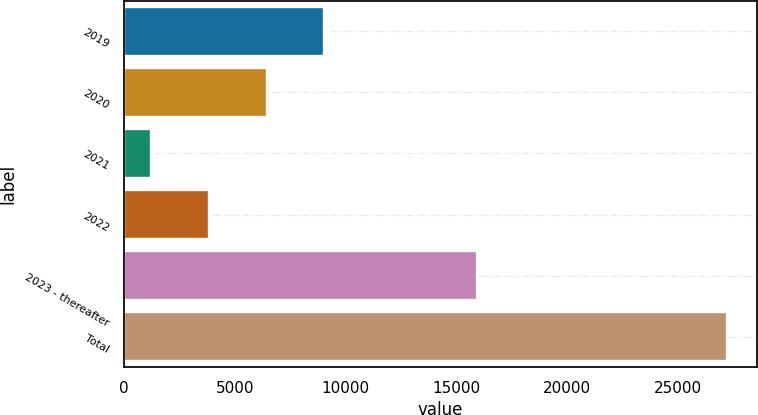Convert chart. <chart><loc_0><loc_0><loc_500><loc_500><bar_chart><fcel>2019<fcel>2020<fcel>2021<fcel>2022<fcel>2023 - thereafter<fcel>Total<nl><fcel>9025.3<fcel>6428.2<fcel>1234<fcel>3831.1<fcel>15918<fcel>27205<nl></chart> 